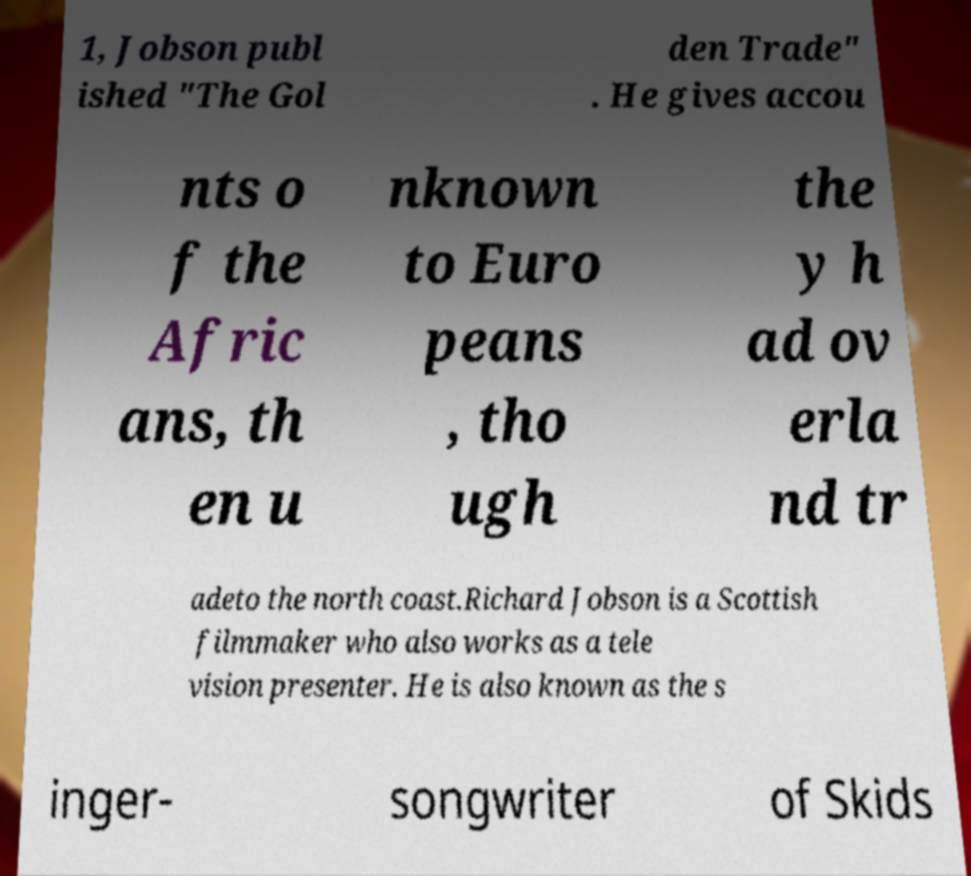I need the written content from this picture converted into text. Can you do that? 1, Jobson publ ished "The Gol den Trade" . He gives accou nts o f the Afric ans, th en u nknown to Euro peans , tho ugh the y h ad ov erla nd tr adeto the north coast.Richard Jobson is a Scottish filmmaker who also works as a tele vision presenter. He is also known as the s inger- songwriter of Skids 